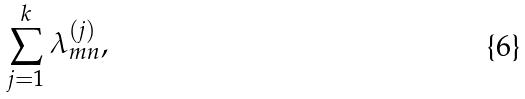Convert formula to latex. <formula><loc_0><loc_0><loc_500><loc_500>\sum ^ { k } _ { j = 1 } \lambda ^ { ( j ) } _ { m n } ,</formula> 